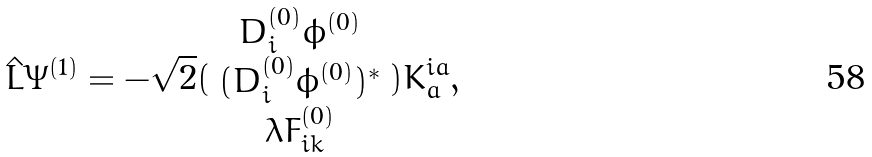<formula> <loc_0><loc_0><loc_500><loc_500>\hat { L } \Psi ^ { ( 1 ) } = - \sqrt { 2 } ( \begin{array} { c } D _ { i } ^ { ( 0 ) } \phi ^ { ( 0 ) } \\ ( D _ { i } ^ { ( 0 ) } \phi ^ { ( 0 ) } ) ^ { \ast } \\ \lambda F _ { i k } ^ { ( 0 ) } \end{array} ) K _ { a } ^ { i a } ,</formula> 